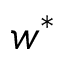Convert formula to latex. <formula><loc_0><loc_0><loc_500><loc_500>w ^ { \ast }</formula> 